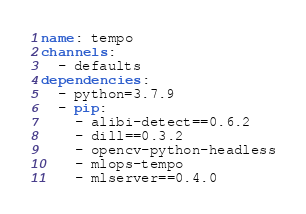Convert code to text. <code><loc_0><loc_0><loc_500><loc_500><_YAML_>name: tempo
channels:
  - defaults
dependencies:
  - python=3.7.9
  - pip:
    - alibi-detect==0.6.2
    - dill==0.3.2
    - opencv-python-headless
    - mlops-tempo
    - mlserver==0.4.0
</code> 